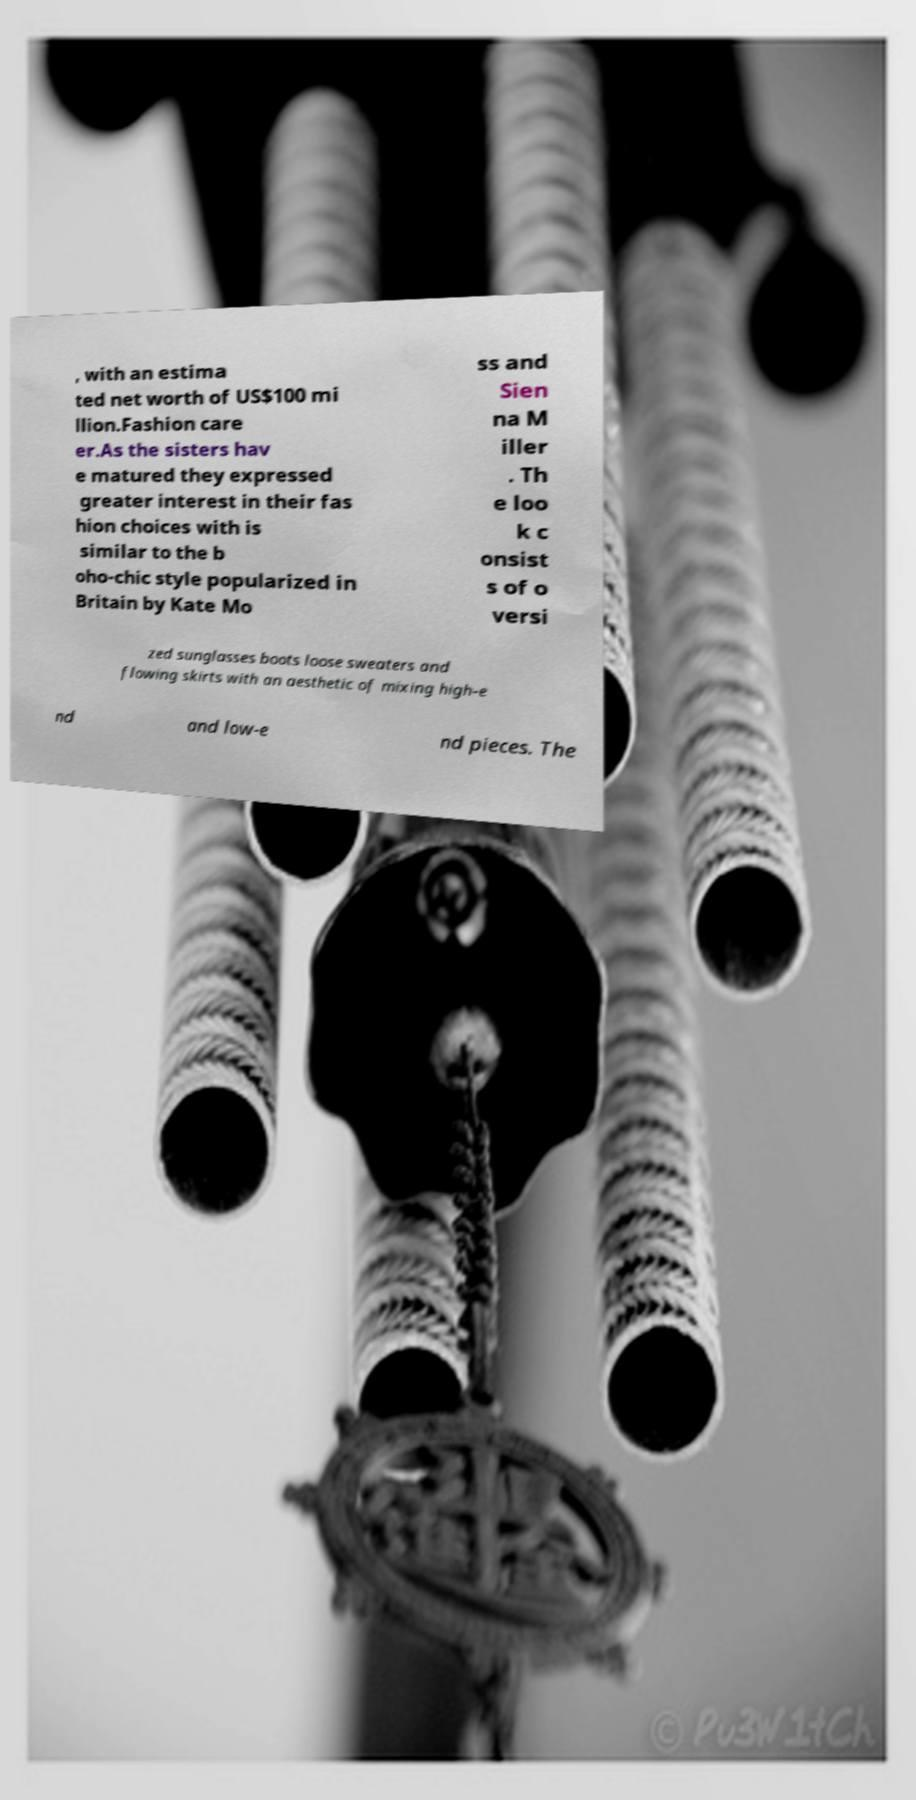I need the written content from this picture converted into text. Can you do that? , with an estima ted net worth of US$100 mi llion.Fashion care er.As the sisters hav e matured they expressed greater interest in their fas hion choices with is similar to the b oho-chic style popularized in Britain by Kate Mo ss and Sien na M iller . Th e loo k c onsist s of o versi zed sunglasses boots loose sweaters and flowing skirts with an aesthetic of mixing high-e nd and low-e nd pieces. The 